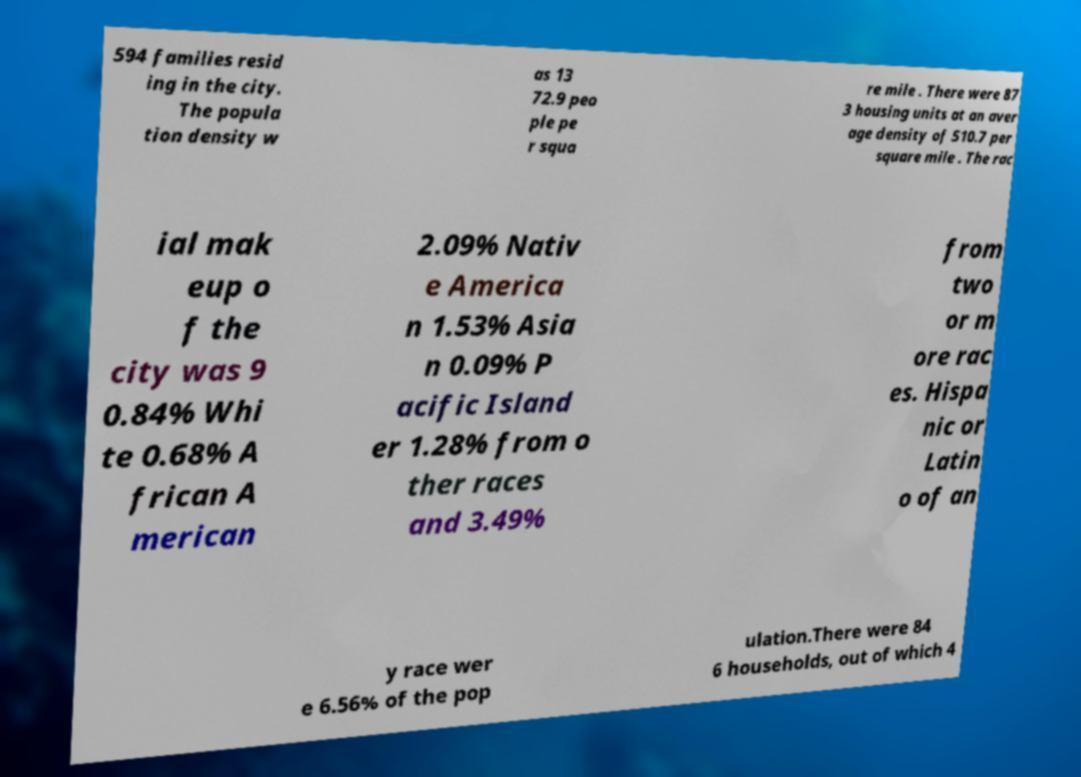Could you extract and type out the text from this image? 594 families resid ing in the city. The popula tion density w as 13 72.9 peo ple pe r squa re mile . There were 87 3 housing units at an aver age density of 510.7 per square mile . The rac ial mak eup o f the city was 9 0.84% Whi te 0.68% A frican A merican 2.09% Nativ e America n 1.53% Asia n 0.09% P acific Island er 1.28% from o ther races and 3.49% from two or m ore rac es. Hispa nic or Latin o of an y race wer e 6.56% of the pop ulation.There were 84 6 households, out of which 4 